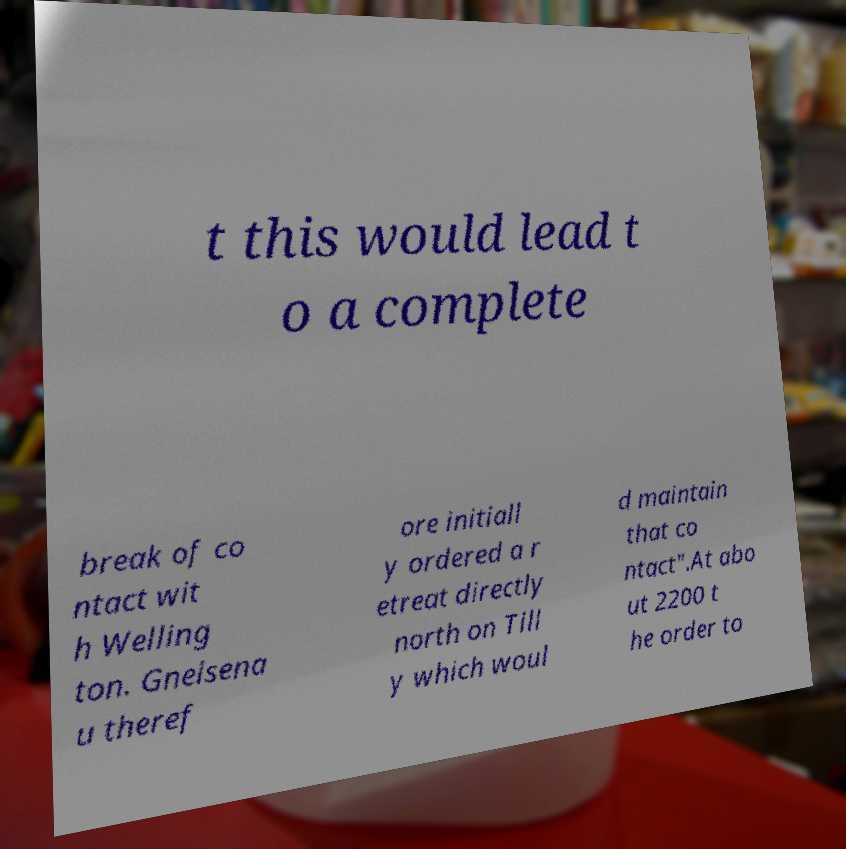Can you accurately transcribe the text from the provided image for me? t this would lead t o a complete break of co ntact wit h Welling ton. Gneisena u theref ore initiall y ordered a r etreat directly north on Till y which woul d maintain that co ntact".At abo ut 2200 t he order to 